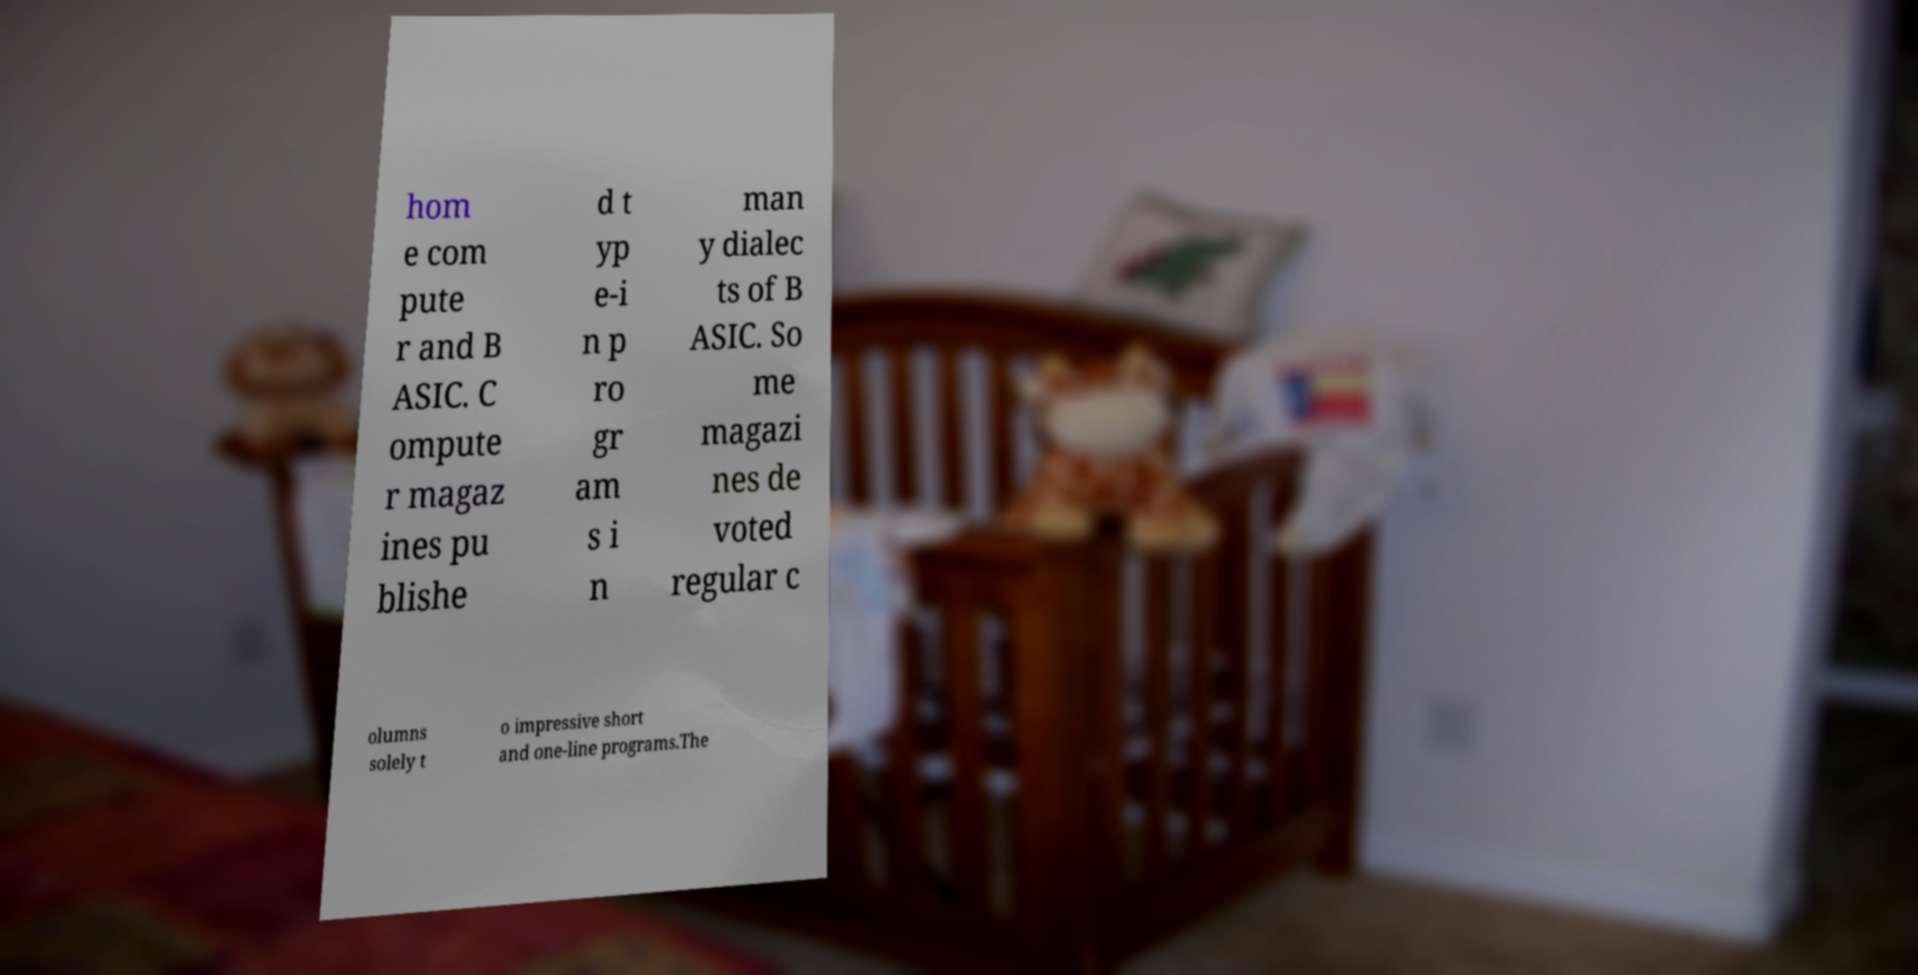What messages or text are displayed in this image? I need them in a readable, typed format. hom e com pute r and B ASIC. C ompute r magaz ines pu blishe d t yp e-i n p ro gr am s i n man y dialec ts of B ASIC. So me magazi nes de voted regular c olumns solely t o impressive short and one-line programs.The 